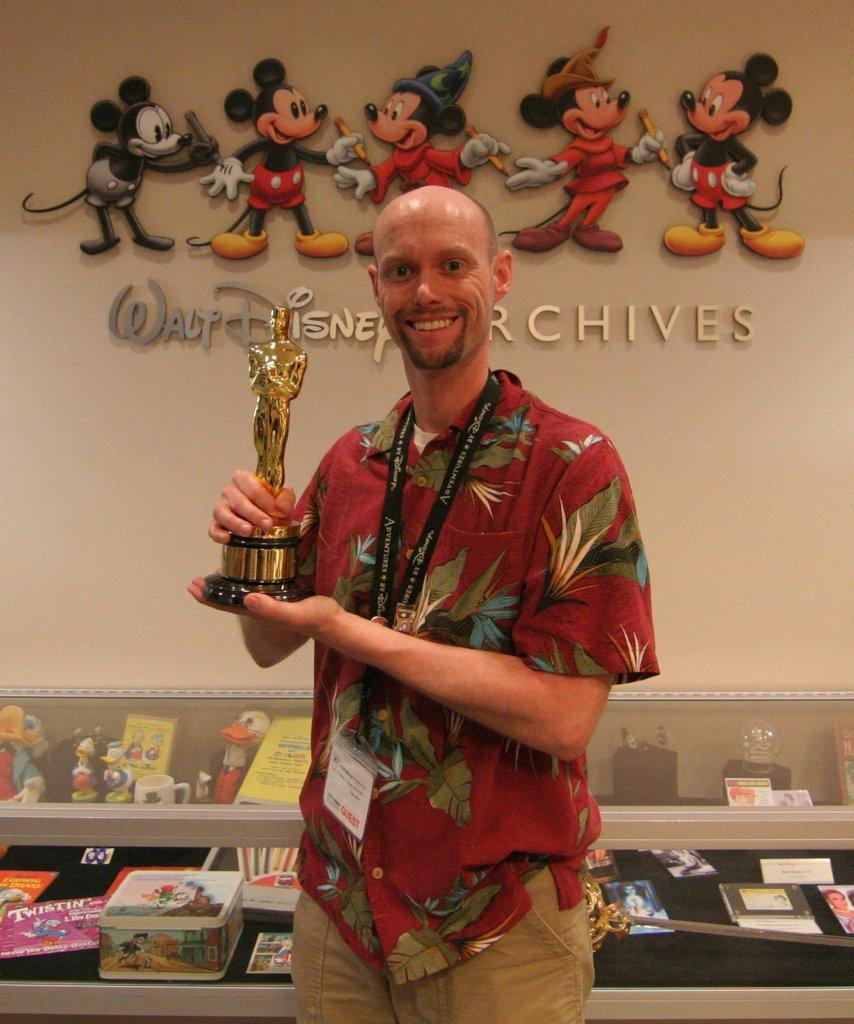What type of structure can be seen in the image? There is a wall in the image. What is located near the wall? There is a statue in the image. Can you describe the person near the statue? There is a man wearing a red color shirt in the image. What other objects can be seen in the image? There are boxes, toys, glasses, and books in the image. What type of wood is used to make the statue in the image? There is no mention of wood being used to make the statue in the image. The statue's material is not specified in the provided facts. 